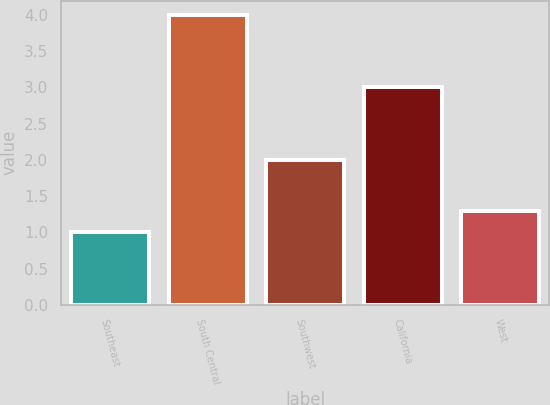Convert chart to OTSL. <chart><loc_0><loc_0><loc_500><loc_500><bar_chart><fcel>Southeast<fcel>South Central<fcel>Southwest<fcel>California<fcel>West<nl><fcel>1<fcel>4<fcel>2<fcel>3<fcel>1.3<nl></chart> 